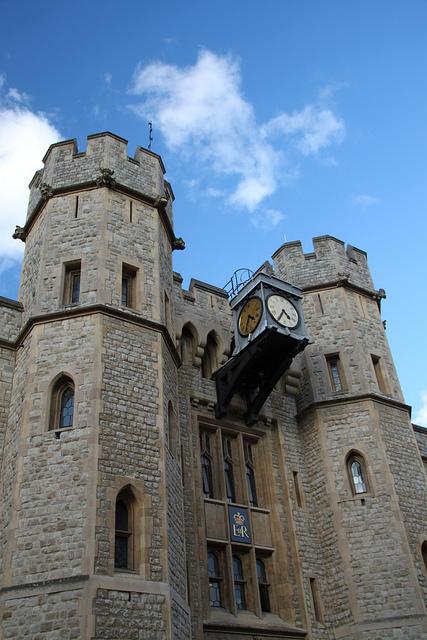How many towers are there?
Answer briefly. 2. What is the weather?
Write a very short answer. Sunny. Could this be a tall tower?
Short answer required. Yes. Are there clocks on the top of the tower?
Give a very brief answer. Yes. What are the balconies constructed of?
Be succinct. Stone. How many panels on either side of the clock?
Be succinct. 2. On which tower is the clock?
Answer briefly. Middle. Would one suspect this edifice of having an interior that stays markedly cool in summer?
Short answer required. Yes. What style of architecture is this?
Quick response, please. Gothic. 